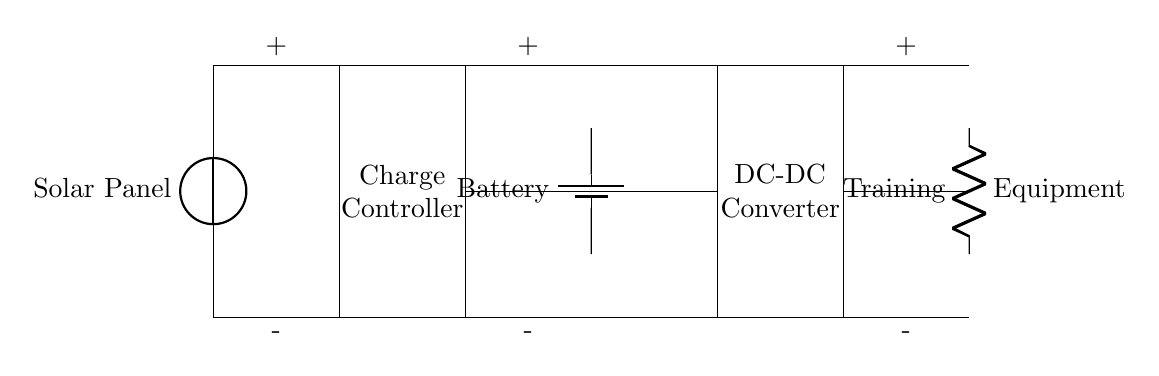What is the first component in the circuit? The first component is the solar panel, which is located at the beginning of the circuit diagram.
Answer: Solar Panel What connects the charge controller to the battery? The charge controller connects to the battery via a direct line at the central part of the circuit, signifying power transfer.
Answer: Direct line What does the DC-DC converter do in this circuit? The DC-DC converter typically changes the voltage levels from the battery to match the requirements of the load, ensuring efficient power delivery.
Answer: Change voltage levels How many resistors are in the training equipment load? There are two resistors in series representing the training equipment's electrical load in the circuit diagram.
Answer: Two What is the voltage configuration for the solar panel? The solar panel has a positive and negative terminal configuration indicated at the top and bottom of the component, representing the voltage source.
Answer: Positive and negative terminals Which component regulates the charge to the battery? The charge controller regulates the charging of the battery by managing input from the solar panel and ensuring safe operation.
Answer: Charge Controller What purpose does the battery serve in this solar-powered circuit? The battery acts as a storage device that collects energy from the solar panel, allowing for power supply during times when sunlight is not available.
Answer: Storage device 